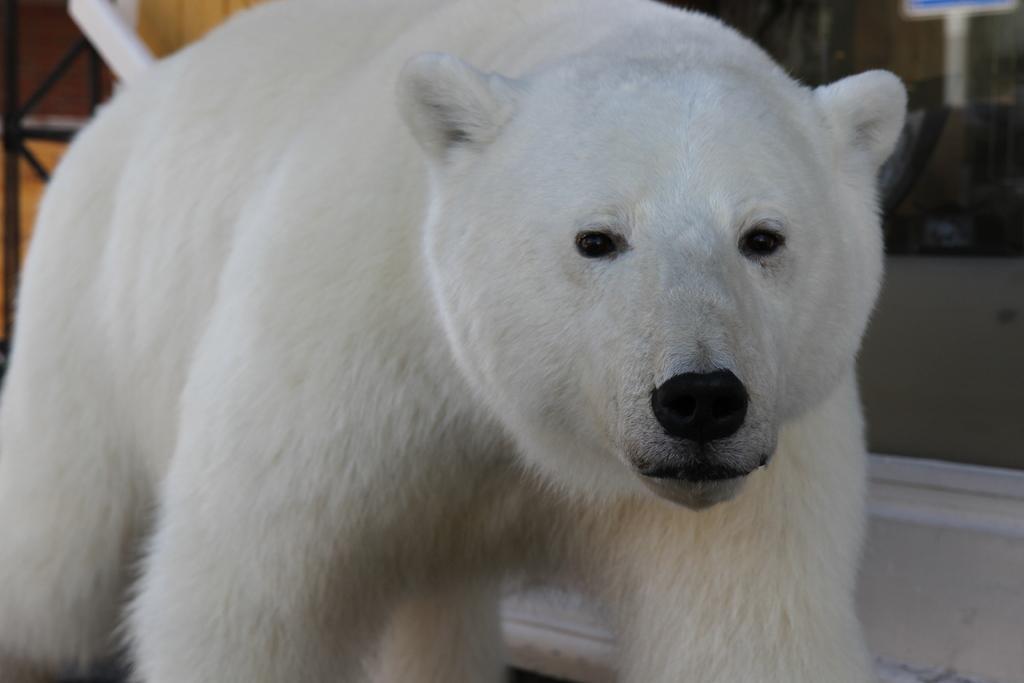In one or two sentences, can you explain what this image depicts? This image consists of a polar bear. It is in white color. 